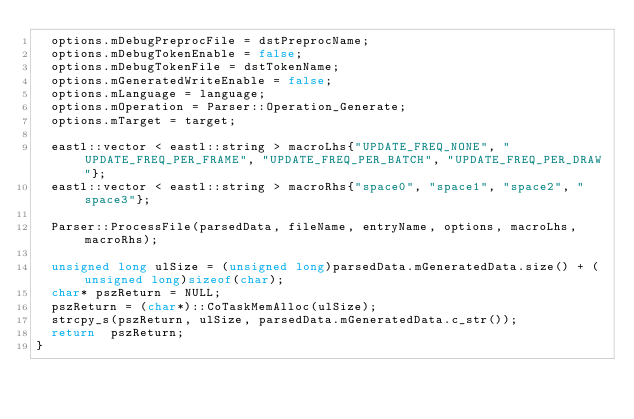Convert code to text. <code><loc_0><loc_0><loc_500><loc_500><_C++_>	options.mDebugPreprocFile = dstPreprocName;
	options.mDebugTokenEnable = false;
	options.mDebugTokenFile = dstTokenName;
	options.mGeneratedWriteEnable = false;
	options.mLanguage = language;
	options.mOperation = Parser::Operation_Generate;
	options.mTarget = target;

	eastl::vector < eastl::string > macroLhs{"UPDATE_FREQ_NONE", "UPDATE_FREQ_PER_FRAME", "UPDATE_FREQ_PER_BATCH", "UPDATE_FREQ_PER_DRAW"};
	eastl::vector < eastl::string > macroRhs{"space0", "space1", "space2", "space3"};

	Parser::ProcessFile(parsedData, fileName, entryName, options, macroLhs, macroRhs);

	unsigned long ulSize = (unsigned long)parsedData.mGeneratedData.size() + (unsigned long)sizeof(char);
	char* pszReturn = NULL;
	pszReturn = (char*)::CoTaskMemAlloc(ulSize);
	strcpy_s(pszReturn, ulSize, parsedData.mGeneratedData.c_str());
	return  pszReturn;
}
</code> 